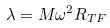Convert formula to latex. <formula><loc_0><loc_0><loc_500><loc_500>\lambda = M \omega ^ { 2 } R _ { T F }</formula> 